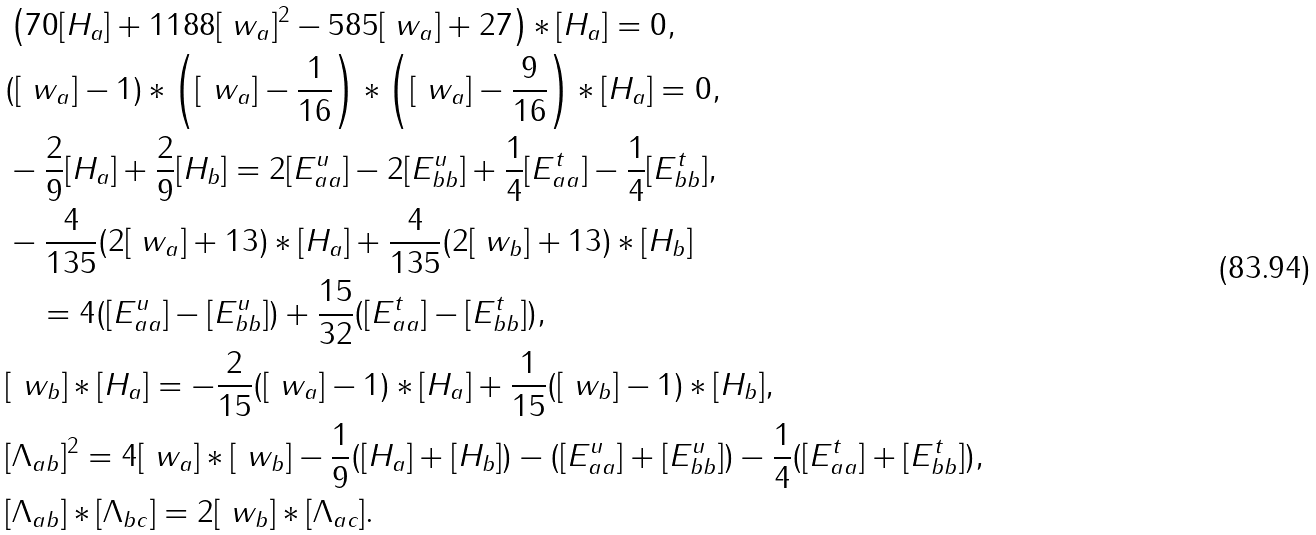<formula> <loc_0><loc_0><loc_500><loc_500>& \left ( 7 0 [ H _ { a } ] + 1 1 8 8 [ \ w _ { a } ] ^ { 2 } - 5 8 5 [ \ w _ { a } ] + 2 7 \right ) * [ H _ { a } ] = 0 , \\ & ( [ \ w _ { a } ] - 1 ) * \left ( [ \ w _ { a } ] - \frac { 1 } { 1 6 } \right ) * \left ( [ \ w _ { a } ] - \frac { 9 } { 1 6 } \right ) * [ H _ { a } ] = 0 , \\ & - \frac { 2 } { 9 } [ H _ { a } ] + \frac { 2 } { 9 } [ H _ { b } ] = 2 [ E _ { a a } ^ { u } ] - 2 [ E _ { b b } ^ { u } ] + \frac { 1 } { 4 } [ E _ { a a } ^ { t } ] - \frac { 1 } { 4 } [ E _ { b b } ^ { t } ] , \\ & - \frac { 4 } { 1 3 5 } ( 2 [ \ w _ { a } ] + 1 3 ) * [ H _ { a } ] + \frac { 4 } { 1 3 5 } ( 2 [ \ w _ { b } ] + 1 3 ) * [ H _ { b } ] \\ & \quad = 4 ( [ E _ { a a } ^ { u } ] - [ E _ { b b } ^ { u } ] ) + \frac { 1 5 } { 3 2 } ( [ E _ { a a } ^ { t } ] - [ E _ { b b } ^ { t } ] ) , \\ & [ \ w _ { b } ] * [ H _ { a } ] = - \frac { 2 } { 1 5 } ( [ \ w _ { a } ] - 1 ) * [ H _ { a } ] + \frac { 1 } { 1 5 } ( [ \ w _ { b } ] - 1 ) * [ H _ { b } ] , \\ & [ \Lambda _ { a b } ] ^ { 2 } = 4 [ \ w _ { a } ] * [ \ w _ { b } ] - \frac { 1 } { 9 } ( [ H _ { a } ] + [ H _ { b } ] ) - ( [ E _ { a a } ^ { u } ] + [ E _ { b b } ^ { u } ] ) - \frac { 1 } { 4 } ( [ E _ { a a } ^ { t } ] + [ E _ { b b } ^ { t } ] ) , \\ & [ \Lambda _ { a b } ] * [ \Lambda _ { b c } ] = 2 [ \ w _ { b } ] * [ \Lambda _ { a c } ] .</formula> 